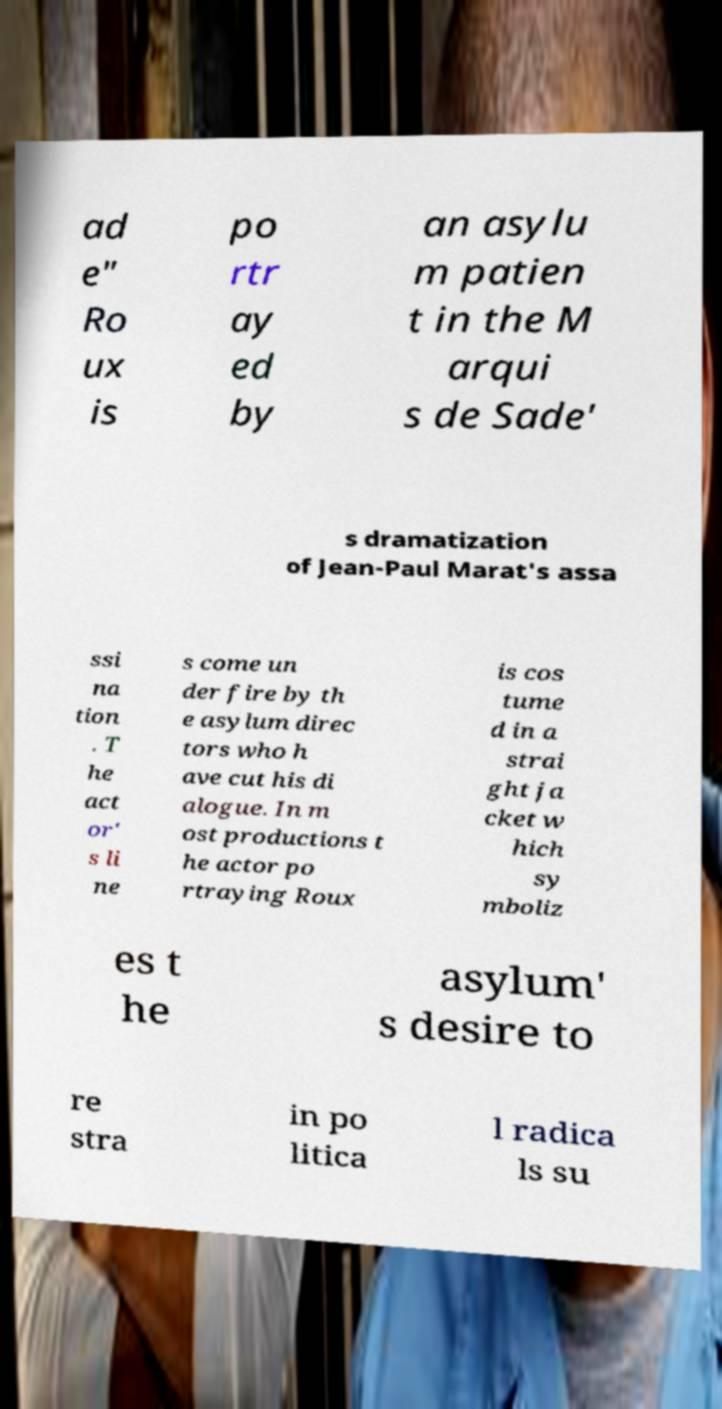Could you assist in decoding the text presented in this image and type it out clearly? ad e" Ro ux is po rtr ay ed by an asylu m patien t in the M arqui s de Sade' s dramatization of Jean-Paul Marat's assa ssi na tion . T he act or' s li ne s come un der fire by th e asylum direc tors who h ave cut his di alogue. In m ost productions t he actor po rtraying Roux is cos tume d in a strai ght ja cket w hich sy mboliz es t he asylum' s desire to re stra in po litica l radica ls su 